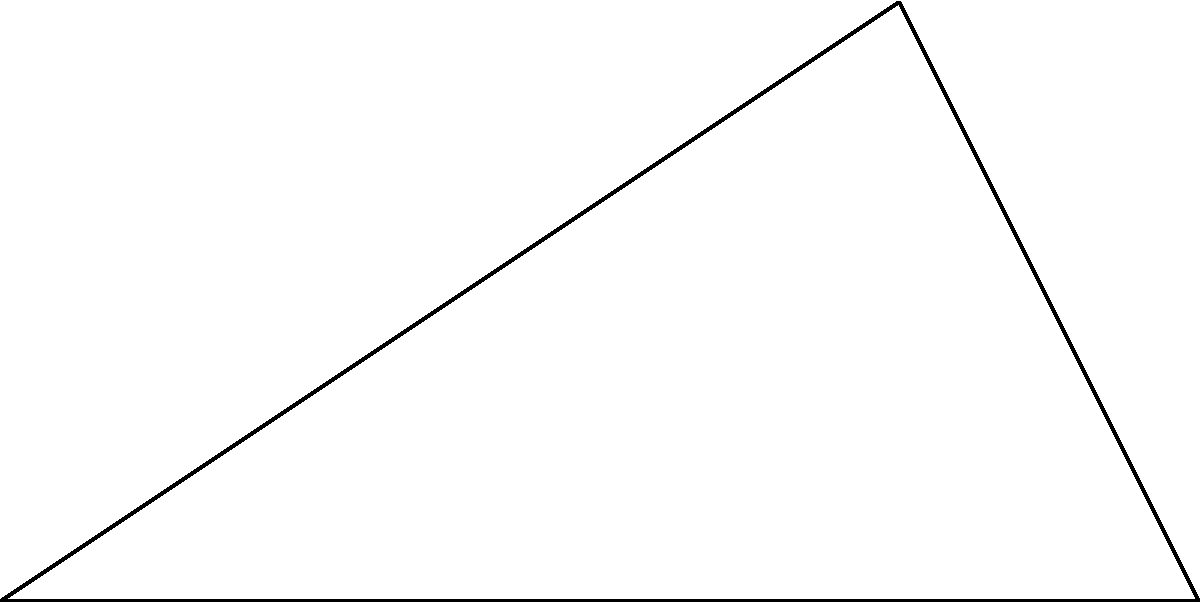As a real estate mogul, you're planning a new development between two existing properties. Using satellite imagery, you've determined that Property A is 6 km away from the satellite's position, Property B is 4 km away from the satellite, and the angle between these two lines of sight is $\theta$. If the satellite's view forms a right angle with the line between Properties A and B, what is the distance between these two properties? Round your answer to the nearest meter. Let's approach this step-by-step:

1) We can use the Pythagorean theorem to solve this problem. The two properties and the satellite form a right-angled triangle.

2) Let's denote the distance between Properties A and B as x km.

3) We know:
   - The distance from the satellite to Property A is 6 km
   - The distance from the satellite to Property B is 4 km
   - The angle at the satellite is a right angle (90°)

4) Using the Pythagorean theorem:

   $x^2 + 4^2 = 6^2$

5) Simplify:
   $x^2 + 16 = 36$

6) Subtract 16 from both sides:
   $x^2 = 20$

7) Take the square root of both sides:
   $x = \sqrt{20}$

8) Simplify:
   $x = 2\sqrt{5}$

9) Convert to kilometers:
   $x \approx 4.472135955$ km

10) Round to the nearest meter:
    $x \approx 4,472$ m

Therefore, the distance between Properties A and B is approximately 4,472 meters.
Answer: 4,472 m 